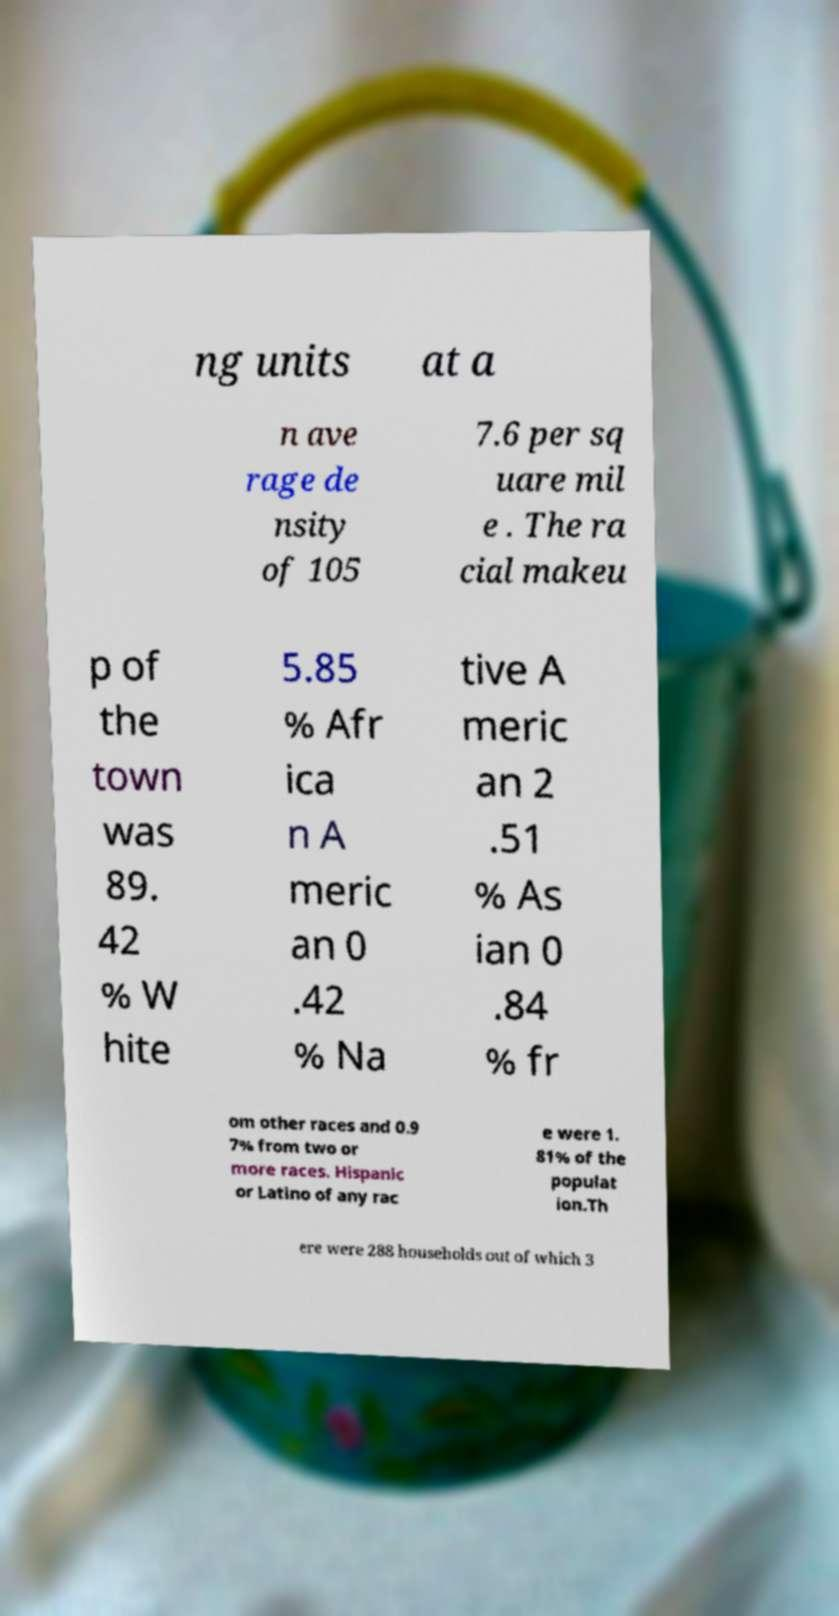I need the written content from this picture converted into text. Can you do that? ng units at a n ave rage de nsity of 105 7.6 per sq uare mil e . The ra cial makeu p of the town was 89. 42 % W hite 5.85 % Afr ica n A meric an 0 .42 % Na tive A meric an 2 .51 % As ian 0 .84 % fr om other races and 0.9 7% from two or more races. Hispanic or Latino of any rac e were 1. 81% of the populat ion.Th ere were 288 households out of which 3 